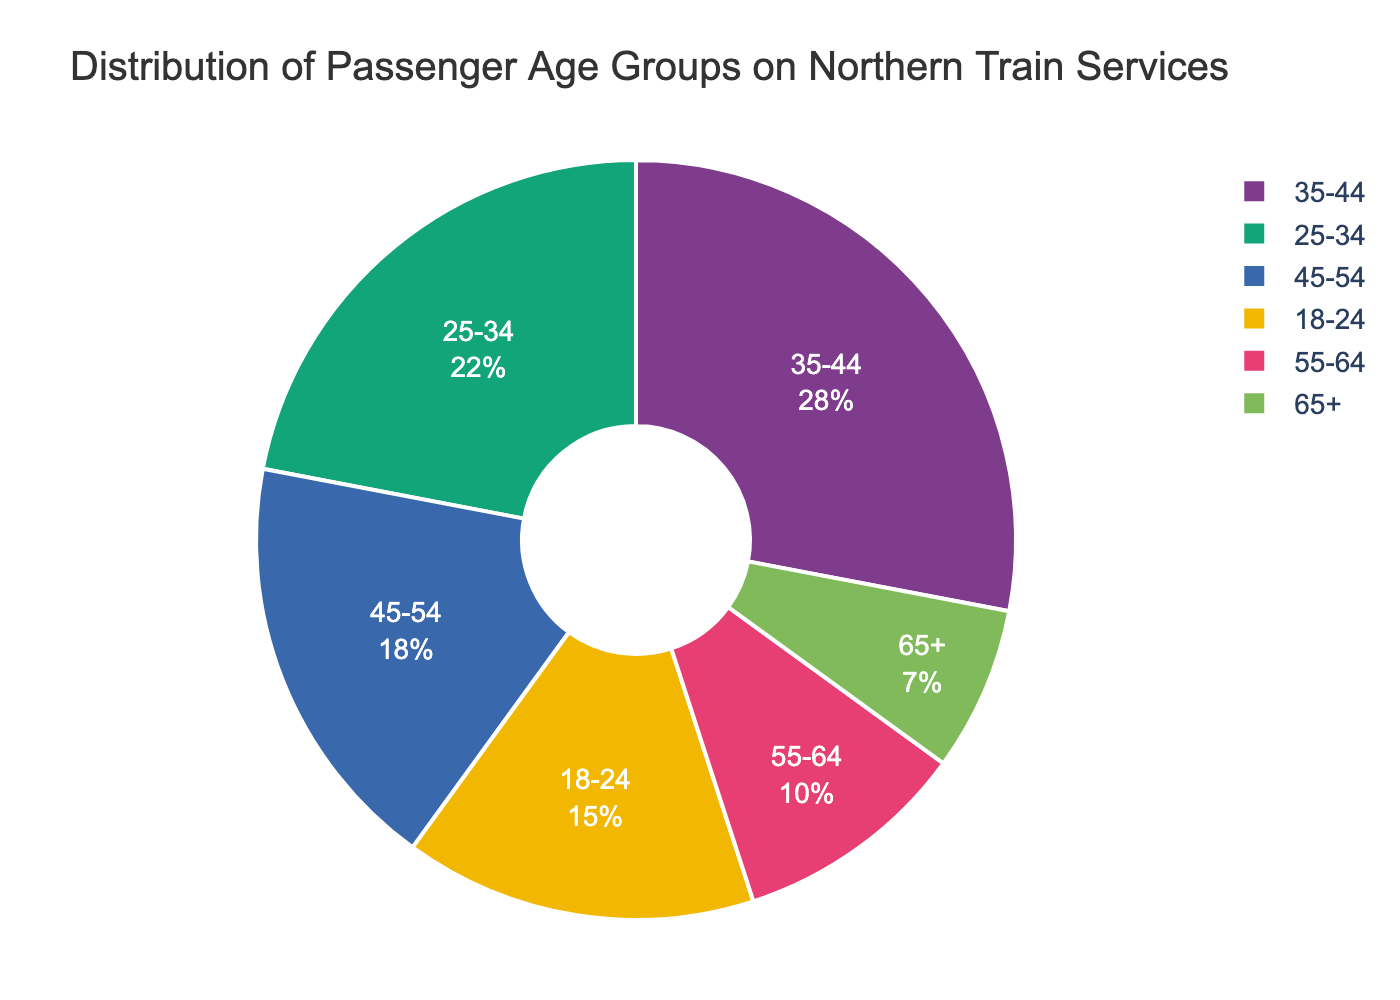What's the largest age group among passengers on Northern train services? The pie chart shows different age groups with their corresponding percentages. The 35-44 age group has the highest percentage at 28%.
Answer: 35-44 What percentage of passengers are under 34 years old? To find the percentage of passengers under 34 years old, sum the percentages of the 18-24 and 25-34 age groups: 15% + 22% = 37%.
Answer: 37% Which age group has the smallest proportion of passengers? By looking at the pie chart, the age group with the smallest percentage is the 65+ age group at 7%.
Answer: 65+ How much larger is the 35-44 age group compared to the 65+ age group? To find the difference between the 35-44 age group and the 65+ age group, subtract the percentage of 65+ from the percentage of 35-44: 28% - 7% = 21%.
Answer: 21% Are there more passengers in the 45-54 age group or the 55-64 age group? Comparing the percentages, the 45-54 age group has 18% and the 55-64 age group has 10%. So, the 45-54 age group has more passengers.
Answer: 45-54 What is the combined percentage of passengers aged 45 and above? Sum the percentages of the age groups 45-54, 55-64, and 65+: 18% + 10% + 7% = 35%.
Answer: 35% Do passengers in the 18-24 age group make up more or less than 20% of the total? The percentage for the 18-24 age group is explicitly shown as 15%, which is less than 20%.
Answer: Less Which color represents the 25-34 age group? The pie chart uses different colors for each age group. The 25-34 age group is represented by a specific color in the chart, which can be identified visually.
Answer: [Answer based on visual inspection] Is the percentage of passengers in the 55-64 age group more than half of the percentage in the 35-44 age group? The percentage of passengers in the 55-64 age group is 10%, while the 35-44 age group is 28%. Half of 28% is 14%, which is greater than 10%.
Answer: No 